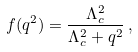<formula> <loc_0><loc_0><loc_500><loc_500>f ( q ^ { 2 } ) = \frac { \Lambda _ { c } ^ { 2 } } { \Lambda _ { c } ^ { 2 } + q ^ { 2 } } \, ,</formula> 